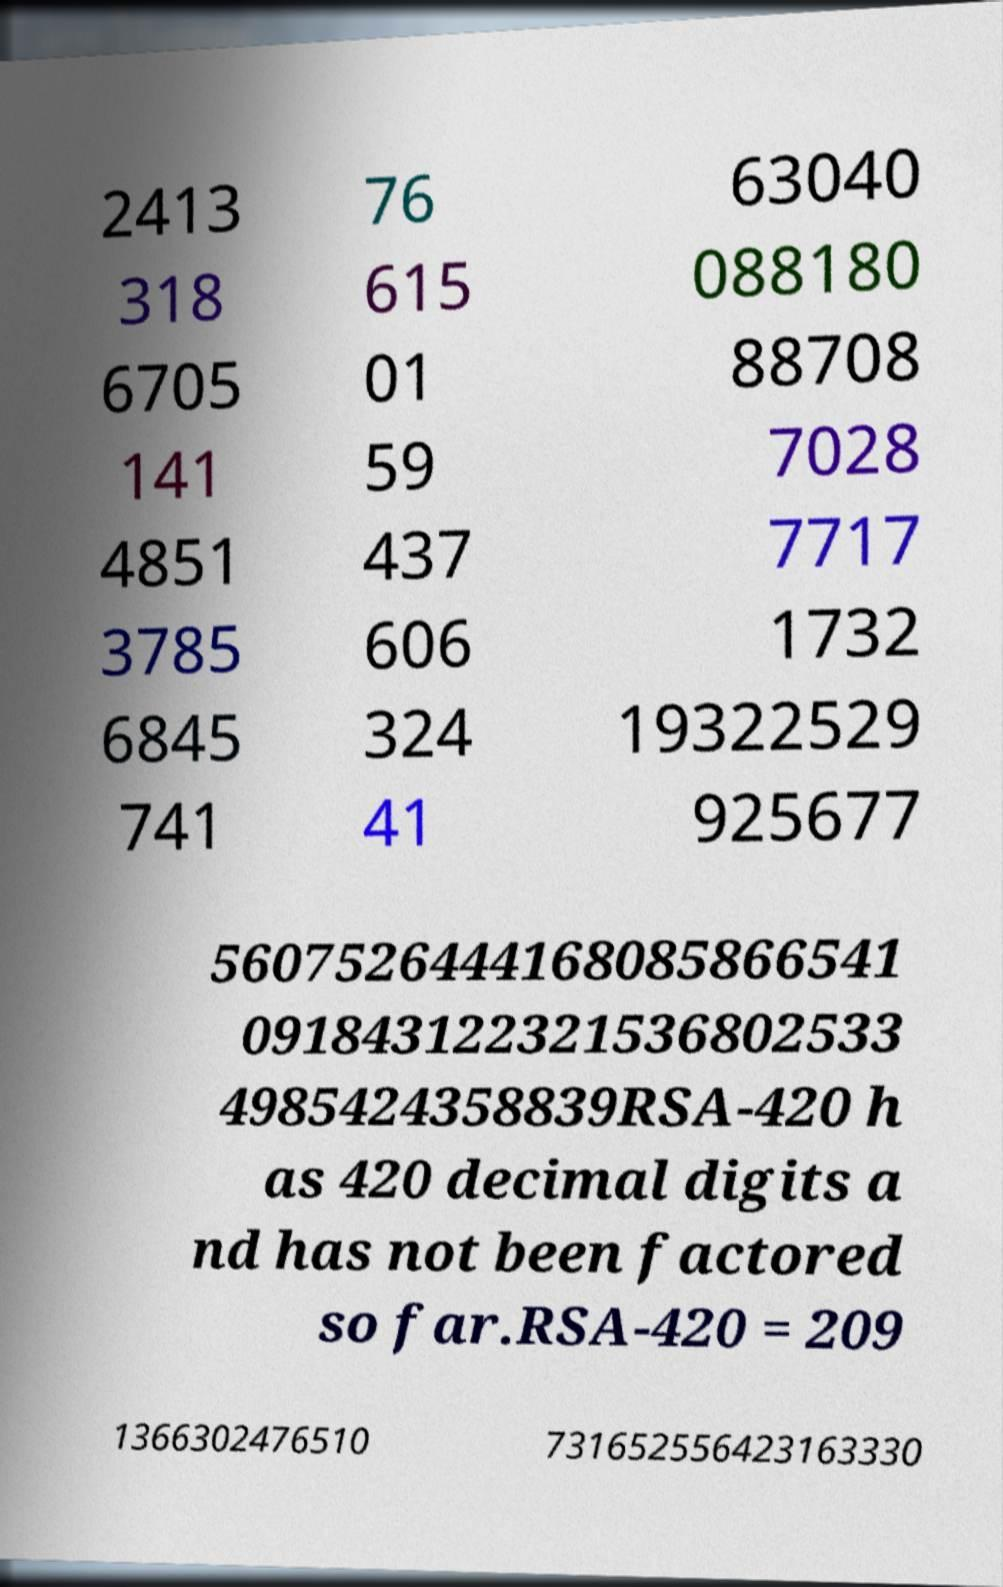Can you read and provide the text displayed in the image?This photo seems to have some interesting text. Can you extract and type it out for me? 2413 318 6705 141 4851 3785 6845 741 76 615 01 59 437 606 324 41 63040 088180 88708 7028 7717 1732 19322529 925677 5607526444168085866541 091843122321536802533 4985424358839RSA-420 h as 420 decimal digits a nd has not been factored so far.RSA-420 = 209 1366302476510 731652556423163330 